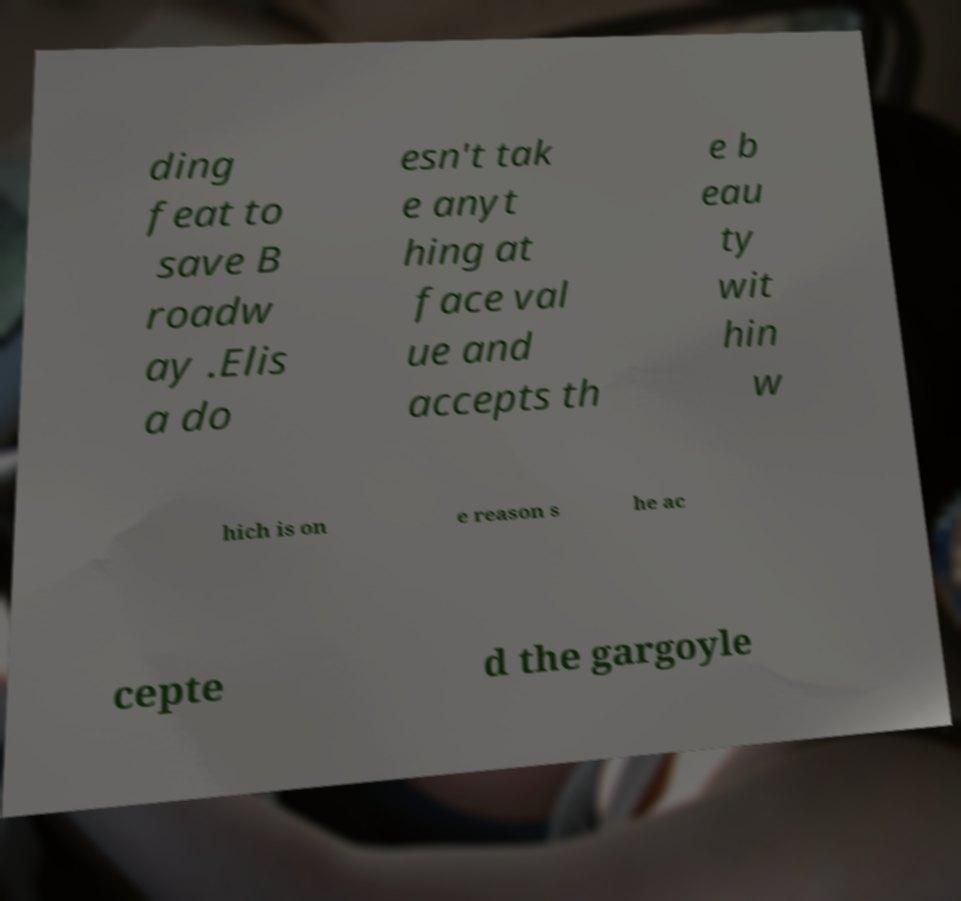Please read and relay the text visible in this image. What does it say? ding feat to save B roadw ay .Elis a do esn't tak e anyt hing at face val ue and accepts th e b eau ty wit hin w hich is on e reason s he ac cepte d the gargoyle 